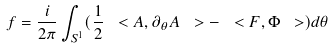Convert formula to latex. <formula><loc_0><loc_0><loc_500><loc_500>f = \frac { i } { 2 \pi } \int _ { S ^ { 1 } } ( \frac { 1 } { 2 } \ < A , \partial _ { \theta } A \ > - \ < F , \Phi \ > ) d \theta</formula> 